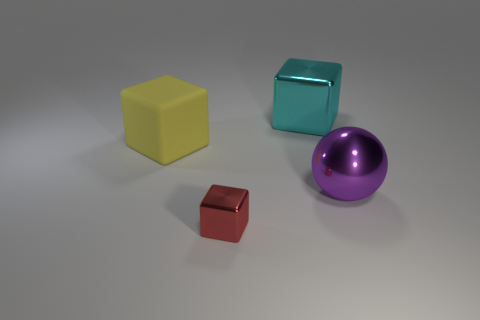Is there any other thing that has the same size as the red thing?
Provide a succinct answer. No. Is there any other thing that has the same material as the yellow thing?
Your answer should be very brief. No. The yellow thing has what shape?
Provide a short and direct response. Cube. There is a cube on the left side of the tiny object; what material is it?
Offer a very short reply. Rubber. There is a shiny object that is behind the big metal object in front of the object on the left side of the small red shiny thing; how big is it?
Keep it short and to the point. Large. Does the rubber block have the same size as the shiny object behind the large purple metal sphere?
Make the answer very short. Yes. What is the color of the large block that is behind the big yellow block?
Your answer should be very brief. Cyan. There is a large metal thing that is behind the yellow cube; what shape is it?
Make the answer very short. Cube. What number of cyan objects are either metallic things or big metallic blocks?
Offer a very short reply. 1. Is the yellow block made of the same material as the tiny red object?
Offer a very short reply. No. 